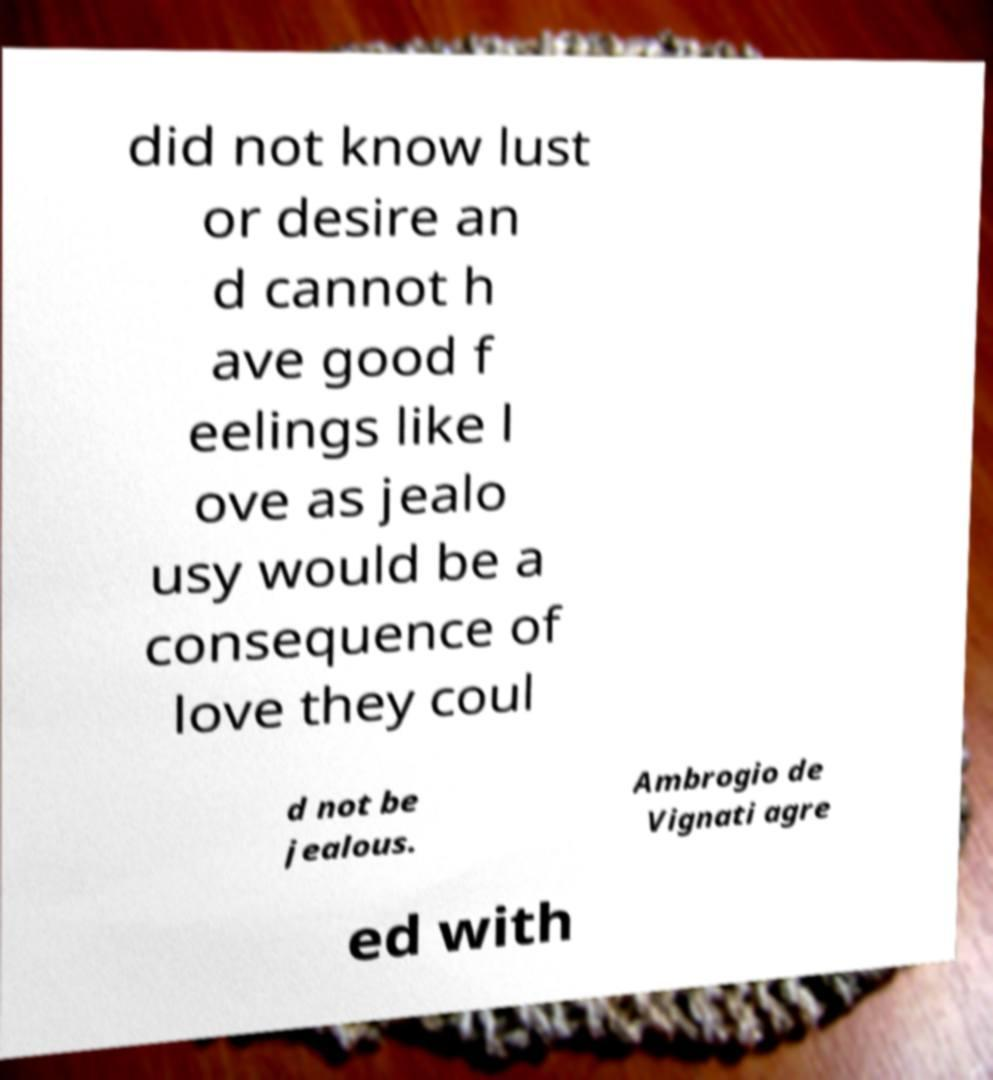What messages or text are displayed in this image? I need them in a readable, typed format. did not know lust or desire an d cannot h ave good f eelings like l ove as jealo usy would be a consequence of love they coul d not be jealous. Ambrogio de Vignati agre ed with 